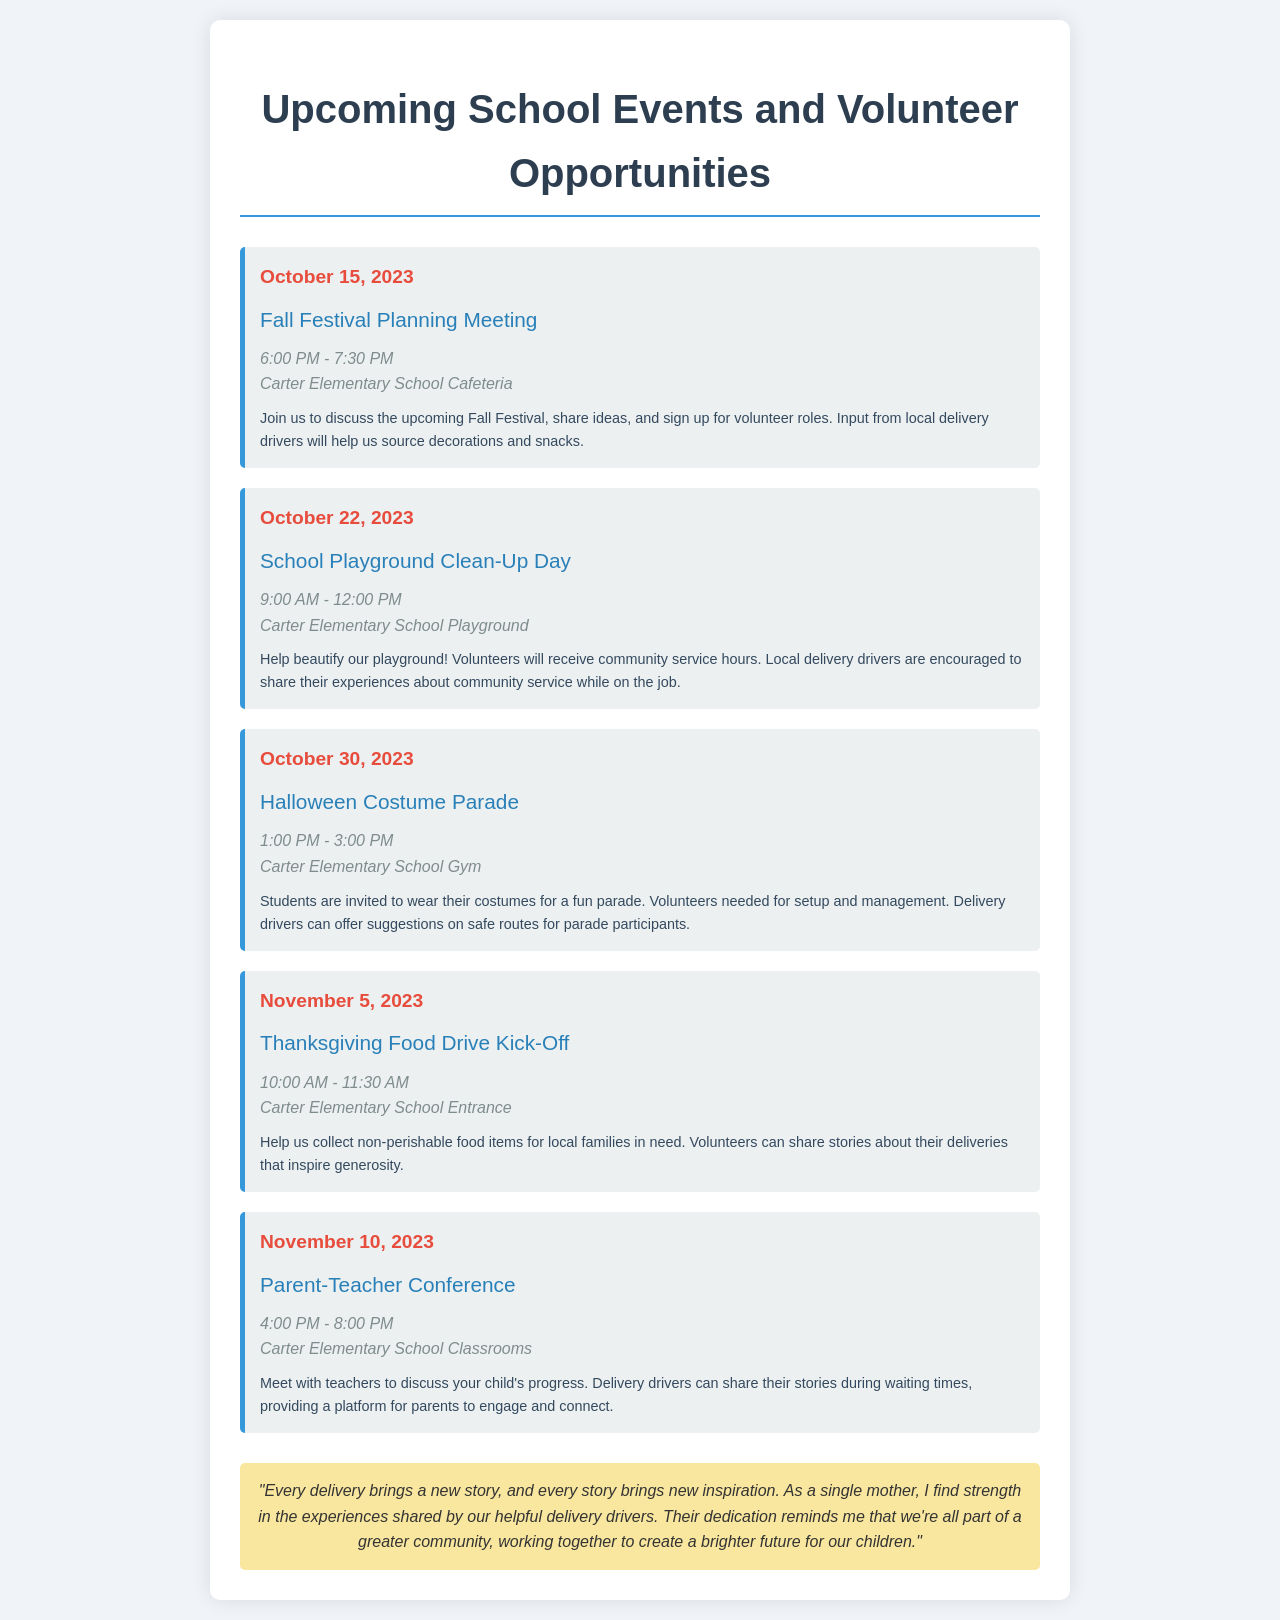What is the date of the Fall Festival Planning Meeting? The document specifies that the Fall Festival Planning Meeting occurs on October 15, 2023.
Answer: October 15, 2023 What time does the School Playground Clean-Up Day start? According to the document, the School Playground Clean-Up Day begins at 9:00 AM.
Answer: 9:00 AM Where will the Halloween Costume Parade take place? The document indicates that the Halloween Costume Parade will be held in the Carter Elementary School Gym.
Answer: Carter Elementary School Gym How long is the Parent-Teacher Conference scheduled for? The document states that the Parent-Teacher Conference is scheduled from 4:00 PM to 8:00 PM, which is 4 hours.
Answer: 4 hours What is the main purpose of the Thanksgiving Food Drive Kick-Off? The document explains that the Thanksgiving Food Drive Kick-Off aims to collect non-perishable food items for local families in need.
Answer: Collect non-perishable food items Are delivery drivers encouraged to share experiences during the Playground Clean-Up Day? The document mentions that local delivery drivers are encouraged to share their experiences about community service during the Playground Clean-Up Day.
Answer: Yes How can volunteer participation at the Halloween Costume Parade help with safety? The document mentions that delivery drivers can offer suggestions on safe routes for parade participants.
Answer: Offer suggestions on safe routes What type of items are collected during the Thanksgiving Food Drive? The document outlines that non-perishable food items are collected during the Thanksgiving Food Drive.
Answer: Non-perishable food items What is the setting for the Parent-Teacher Conference? The document states that the Parent-Teacher Conference will take place in the Carter Elementary School Classrooms.
Answer: Carter Elementary School Classrooms 